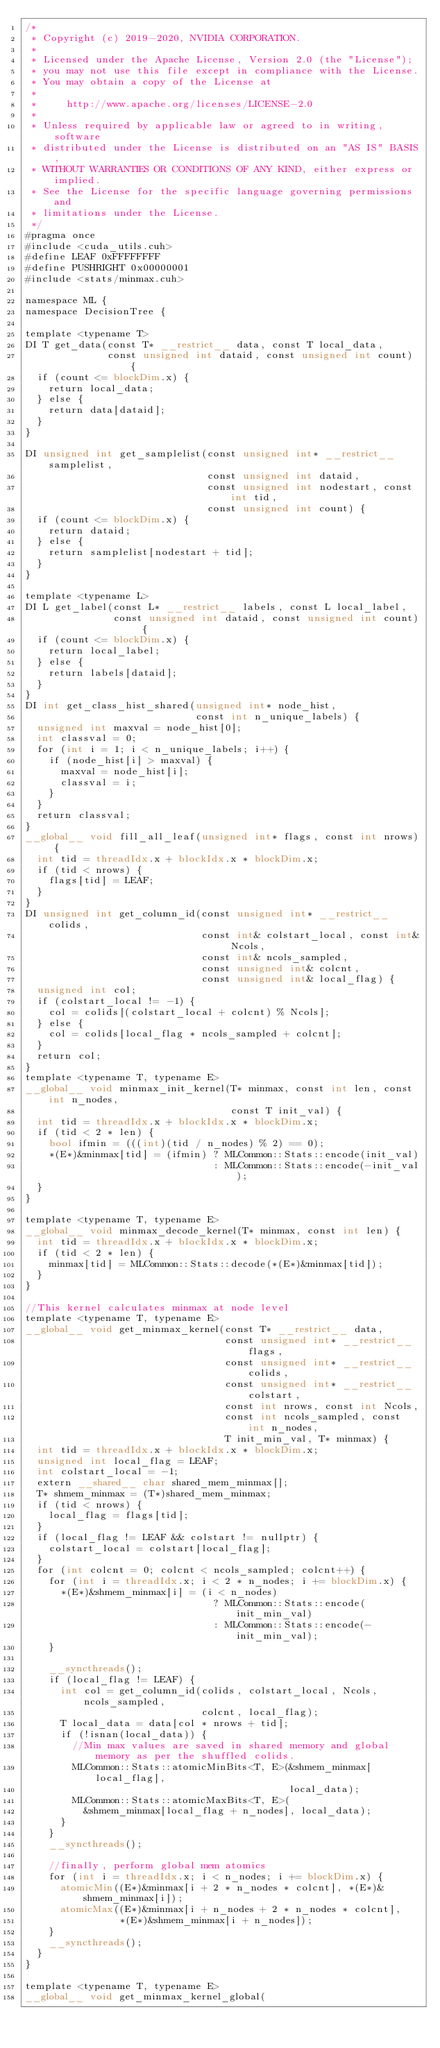<code> <loc_0><loc_0><loc_500><loc_500><_Cuda_>/*
 * Copyright (c) 2019-2020, NVIDIA CORPORATION.
 *
 * Licensed under the Apache License, Version 2.0 (the "License");
 * you may not use this file except in compliance with the License.
 * You may obtain a copy of the License at
 *
 *     http://www.apache.org/licenses/LICENSE-2.0
 *
 * Unless required by applicable law or agreed to in writing, software
 * distributed under the License is distributed on an "AS IS" BASIS,
 * WITHOUT WARRANTIES OR CONDITIONS OF ANY KIND, either express or implied.
 * See the License for the specific language governing permissions and
 * limitations under the License.
 */
#pragma once
#include <cuda_utils.cuh>
#define LEAF 0xFFFFFFFF
#define PUSHRIGHT 0x00000001
#include <stats/minmax.cuh>

namespace ML {
namespace DecisionTree {

template <typename T>
DI T get_data(const T* __restrict__ data, const T local_data,
              const unsigned int dataid, const unsigned int count) {
  if (count <= blockDim.x) {
    return local_data;
  } else {
    return data[dataid];
  }
}

DI unsigned int get_samplelist(const unsigned int* __restrict__ samplelist,
                               const unsigned int dataid,
                               const unsigned int nodestart, const int tid,
                               const unsigned int count) {
  if (count <= blockDim.x) {
    return dataid;
  } else {
    return samplelist[nodestart + tid];
  }
}

template <typename L>
DI L get_label(const L* __restrict__ labels, const L local_label,
               const unsigned int dataid, const unsigned int count) {
  if (count <= blockDim.x) {
    return local_label;
  } else {
    return labels[dataid];
  }
}
DI int get_class_hist_shared(unsigned int* node_hist,
                             const int n_unique_labels) {
  unsigned int maxval = node_hist[0];
  int classval = 0;
  for (int i = 1; i < n_unique_labels; i++) {
    if (node_hist[i] > maxval) {
      maxval = node_hist[i];
      classval = i;
    }
  }
  return classval;
}
__global__ void fill_all_leaf(unsigned int* flags, const int nrows) {
  int tid = threadIdx.x + blockIdx.x * blockDim.x;
  if (tid < nrows) {
    flags[tid] = LEAF;
  }
}
DI unsigned int get_column_id(const unsigned int* __restrict__ colids,
                              const int& colstart_local, const int& Ncols,
                              const int& ncols_sampled,
                              const unsigned int& colcnt,
                              const unsigned int& local_flag) {
  unsigned int col;
  if (colstart_local != -1) {
    col = colids[(colstart_local + colcnt) % Ncols];
  } else {
    col = colids[local_flag * ncols_sampled + colcnt];
  }
  return col;
}
template <typename T, typename E>
__global__ void minmax_init_kernel(T* minmax, const int len, const int n_nodes,
                                   const T init_val) {
  int tid = threadIdx.x + blockIdx.x * blockDim.x;
  if (tid < 2 * len) {
    bool ifmin = (((int)(tid / n_nodes) % 2) == 0);
    *(E*)&minmax[tid] = (ifmin) ? MLCommon::Stats::encode(init_val)
                                : MLCommon::Stats::encode(-init_val);
  }
}

template <typename T, typename E>
__global__ void minmax_decode_kernel(T* minmax, const int len) {
  int tid = threadIdx.x + blockIdx.x * blockDim.x;
  if (tid < 2 * len) {
    minmax[tid] = MLCommon::Stats::decode(*(E*)&minmax[tid]);
  }
}

//This kernel calculates minmax at node level
template <typename T, typename E>
__global__ void get_minmax_kernel(const T* __restrict__ data,
                                  const unsigned int* __restrict__ flags,
                                  const unsigned int* __restrict__ colids,
                                  const unsigned int* __restrict__ colstart,
                                  const int nrows, const int Ncols,
                                  const int ncols_sampled, const int n_nodes,
                                  T init_min_val, T* minmax) {
  int tid = threadIdx.x + blockIdx.x * blockDim.x;
  unsigned int local_flag = LEAF;
  int colstart_local = -1;
  extern __shared__ char shared_mem_minmax[];
  T* shmem_minmax = (T*)shared_mem_minmax;
  if (tid < nrows) {
    local_flag = flags[tid];
  }
  if (local_flag != LEAF && colstart != nullptr) {
    colstart_local = colstart[local_flag];
  }
  for (int colcnt = 0; colcnt < ncols_sampled; colcnt++) {
    for (int i = threadIdx.x; i < 2 * n_nodes; i += blockDim.x) {
      *(E*)&shmem_minmax[i] = (i < n_nodes)
                                ? MLCommon::Stats::encode(init_min_val)
                                : MLCommon::Stats::encode(-init_min_val);
    }

    __syncthreads();
    if (local_flag != LEAF) {
      int col = get_column_id(colids, colstart_local, Ncols, ncols_sampled,
                              colcnt, local_flag);
      T local_data = data[col * nrows + tid];
      if (!isnan(local_data)) {
        //Min max values are saved in shared memory and global memory as per the shuffled colids.
        MLCommon::Stats::atomicMinBits<T, E>(&shmem_minmax[local_flag],
                                             local_data);
        MLCommon::Stats::atomicMaxBits<T, E>(
          &shmem_minmax[local_flag + n_nodes], local_data);
      }
    }
    __syncthreads();

    //finally, perform global mem atomics
    for (int i = threadIdx.x; i < n_nodes; i += blockDim.x) {
      atomicMin((E*)&minmax[i + 2 * n_nodes * colcnt], *(E*)&shmem_minmax[i]);
      atomicMax((E*)&minmax[i + n_nodes + 2 * n_nodes * colcnt],
                *(E*)&shmem_minmax[i + n_nodes]);
    }
    __syncthreads();
  }
}

template <typename T, typename E>
__global__ void get_minmax_kernel_global(</code> 